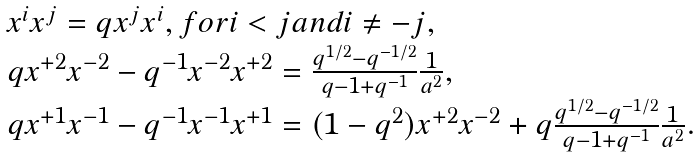<formula> <loc_0><loc_0><loc_500><loc_500>\begin{array} { l } { { x ^ { i } x ^ { j } = q x ^ { j } x ^ { i } , f o r i < j a n d i \not = - j , } } \\ { { q x ^ { + 2 } x ^ { - 2 } - q ^ { - 1 } x ^ { - 2 } x ^ { + 2 } = \frac { q ^ { 1 / 2 } - q ^ { - 1 / 2 } } { q - 1 + q ^ { - 1 } } \frac { 1 } { a ^ { 2 } } , } } \\ { { q x ^ { + 1 } x ^ { - 1 } - q ^ { - 1 } x ^ { - 1 } x ^ { + 1 } = ( 1 - q ^ { 2 } ) x ^ { + 2 } x ^ { - 2 } + q \frac { q ^ { 1 / 2 } - q ^ { - 1 / 2 } } { q - 1 + q ^ { - 1 } } \frac { 1 } { a ^ { 2 } } . } } \end{array}</formula> 